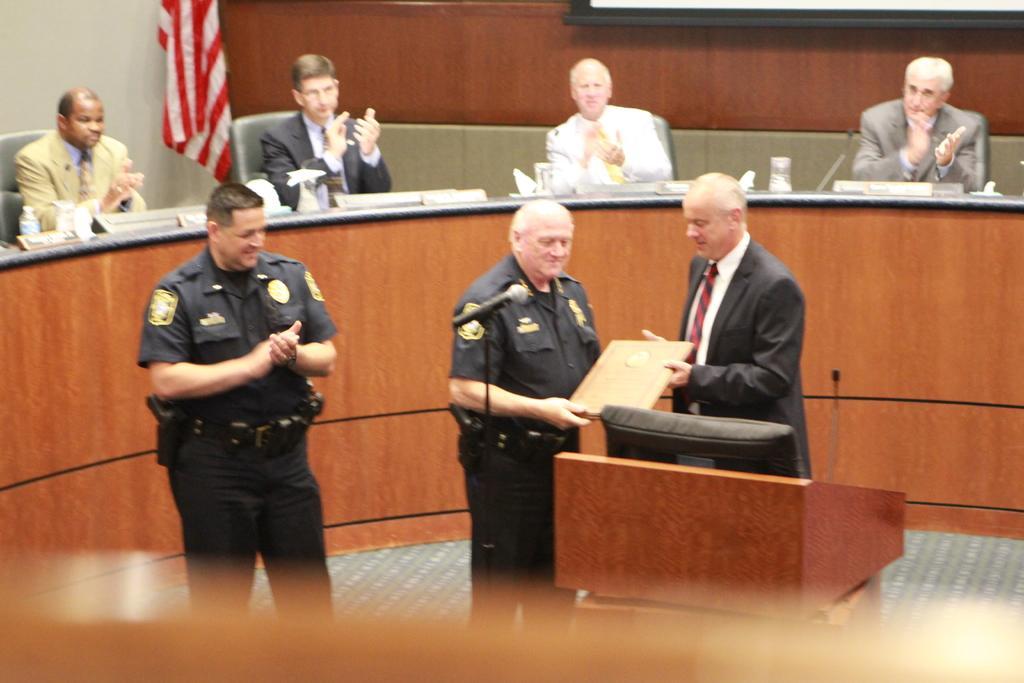Can you describe this image briefly? In this image there is a person wearing suit and tie is presenting a shield to a person wearing a black uniform. Before him there is a mike stand, beside it there is a podium having a mike on it. Left side there is a person wearing a black uniform is standing and clapping his hands. Behind him there is a desk having bottles and few objects on it. Few persons are sitting on the chairs. Top of image there is a flag. Right top there is a display screen. 